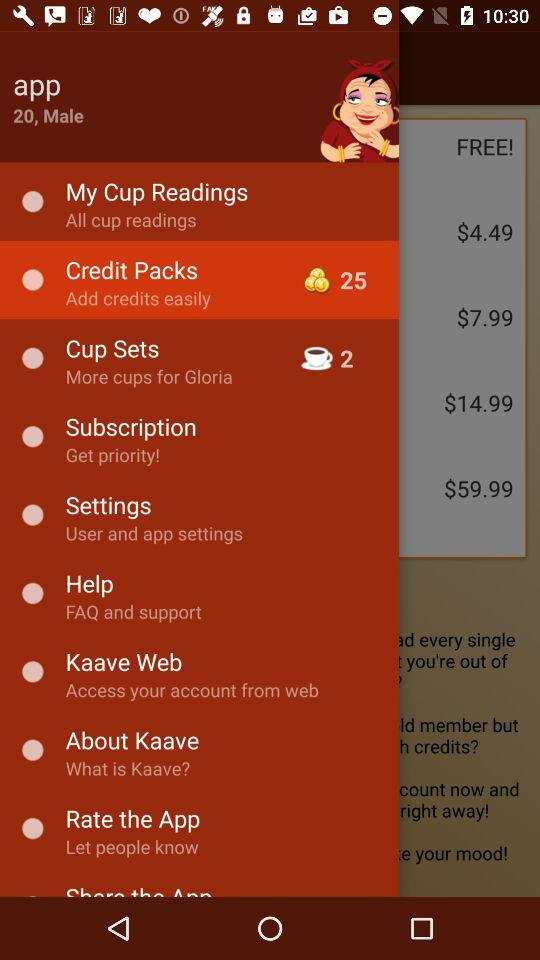What is the price of cup sets?
When the provided information is insufficient, respond with <no answer>. <no answer> 